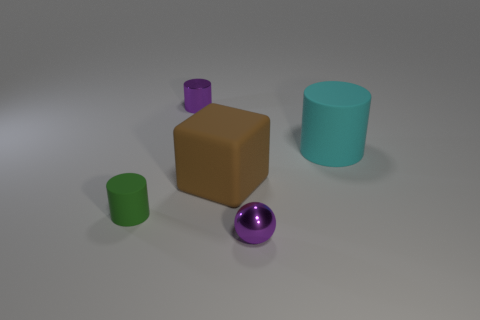What material is the small thing that is to the right of the small green cylinder and behind the tiny purple sphere?
Provide a short and direct response. Metal. Is the material of the cyan object the same as the tiny purple sphere in front of the large brown block?
Your answer should be very brief. No. Is the number of tiny green things in front of the ball greater than the number of matte cubes behind the big brown block?
Make the answer very short. No. What shape is the cyan rubber object?
Offer a terse response. Cylinder. Do the purple thing that is in front of the small green thing and the cylinder on the right side of the tiny shiny ball have the same material?
Your answer should be compact. No. There is a purple metal object that is in front of the green cylinder; what shape is it?
Give a very brief answer. Sphere. What size is the green object that is the same shape as the cyan object?
Offer a very short reply. Small. Does the cube have the same color as the metallic ball?
Ensure brevity in your answer.  No. Is there any other thing that has the same shape as the green thing?
Your answer should be compact. Yes. Is there a small green cylinder that is in front of the matte cylinder left of the tiny metallic cylinder?
Your answer should be very brief. No. 